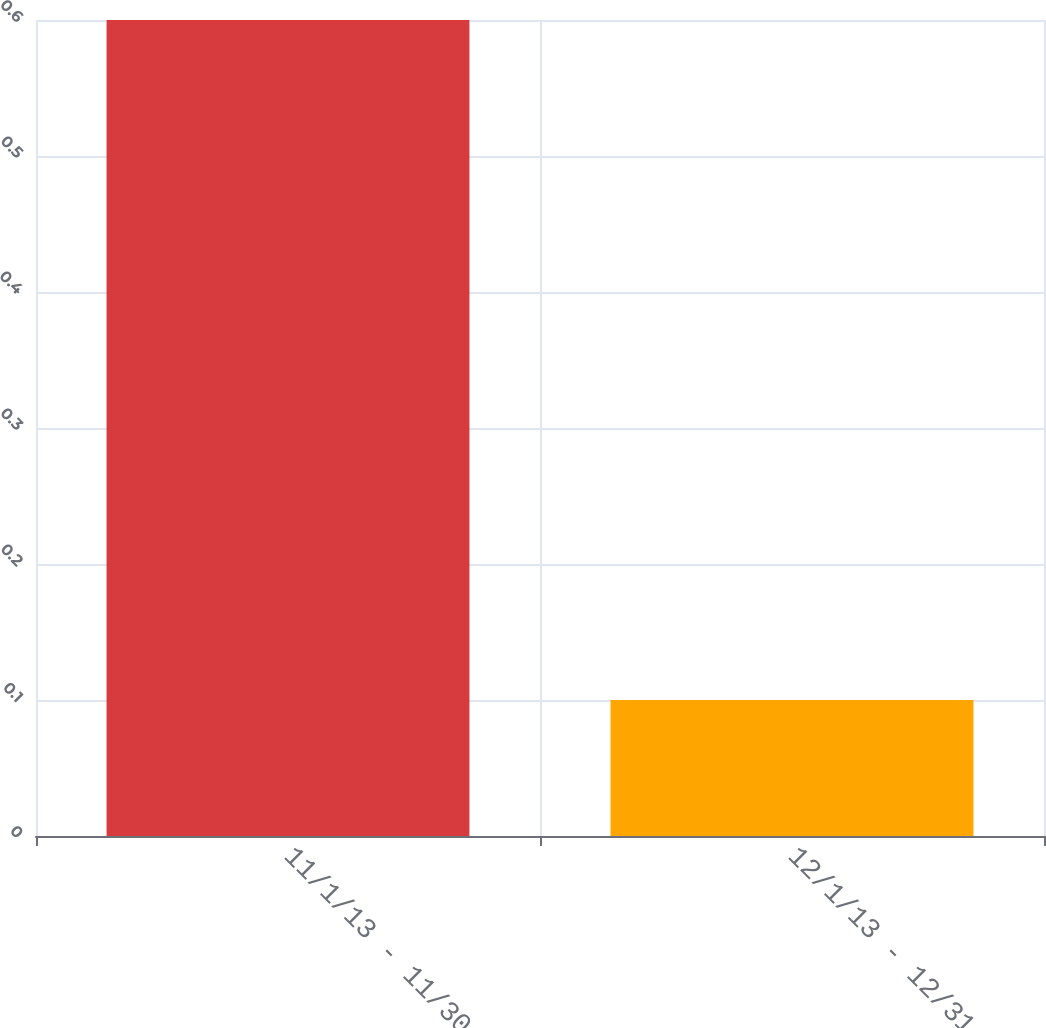<chart> <loc_0><loc_0><loc_500><loc_500><bar_chart><fcel>11/1/13 - 11/30/13<fcel>12/1/13 - 12/31/13<nl><fcel>0.6<fcel>0.1<nl></chart> 